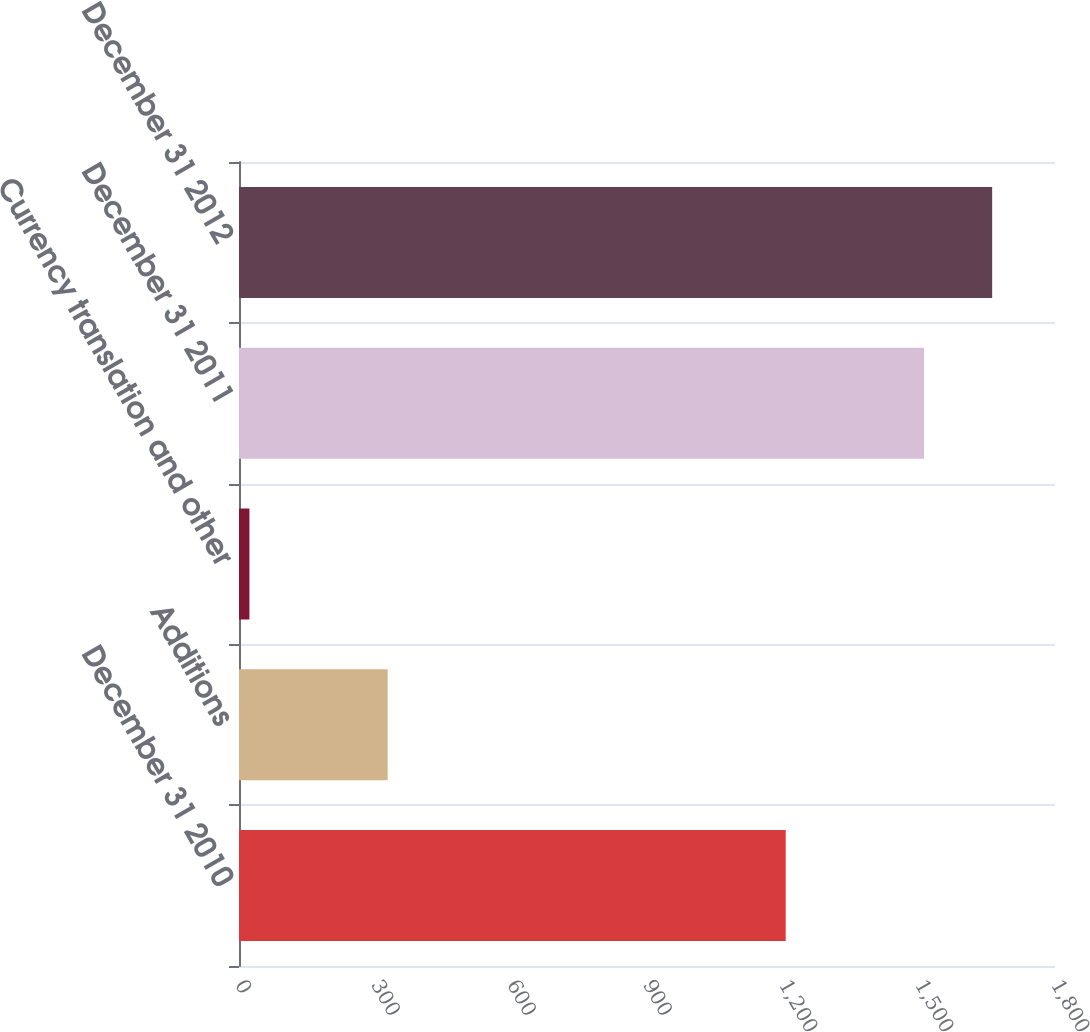<chart> <loc_0><loc_0><loc_500><loc_500><bar_chart><fcel>December 31 2010<fcel>Additions<fcel>Currency translation and other<fcel>December 31 2011<fcel>December 31 2012<nl><fcel>1206<fcel>328<fcel>23<fcel>1511<fcel>1661.4<nl></chart> 